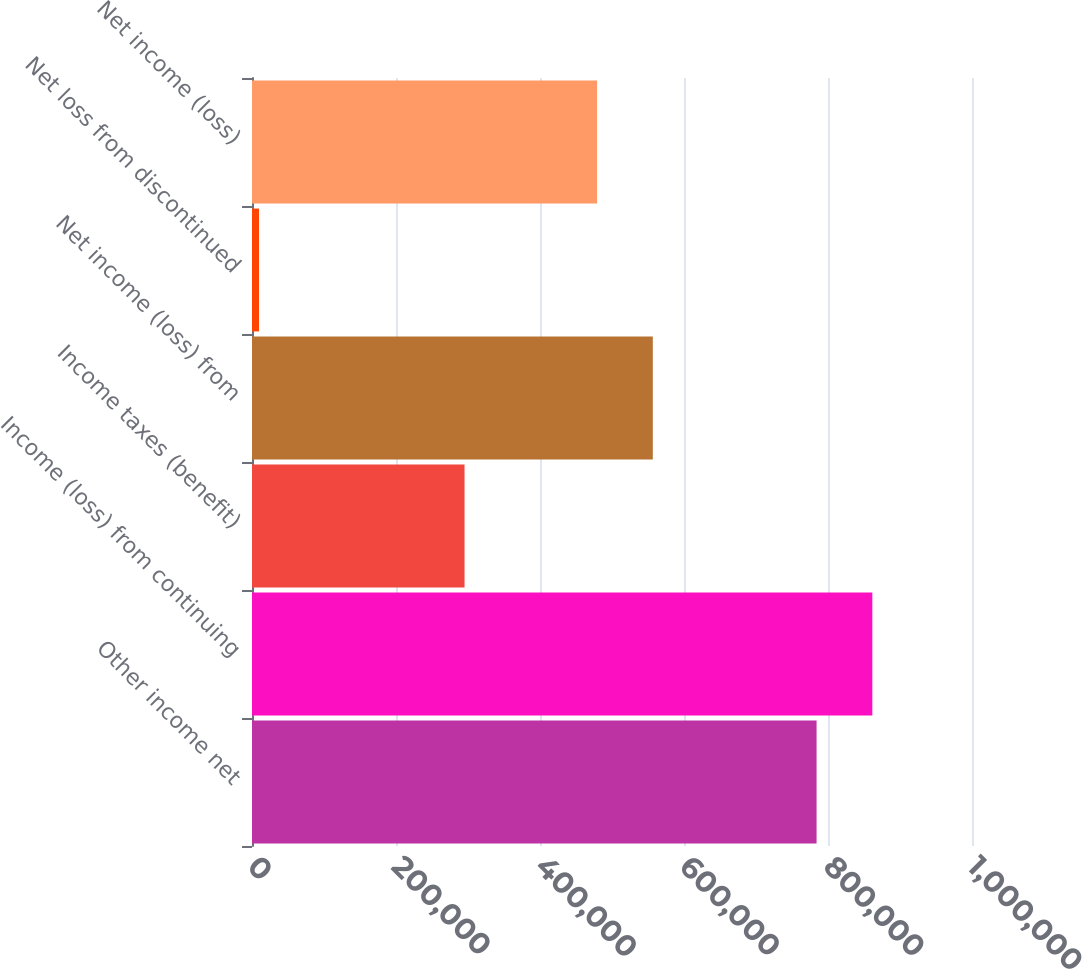<chart> <loc_0><loc_0><loc_500><loc_500><bar_chart><fcel>Other income net<fcel>Income (loss) from continuing<fcel>Income taxes (benefit)<fcel>Net income (loss) from<fcel>Net loss from discontinued<fcel>Net income (loss)<nl><fcel>784135<fcel>861578<fcel>295189<fcel>556685<fcel>9704<fcel>479242<nl></chart> 